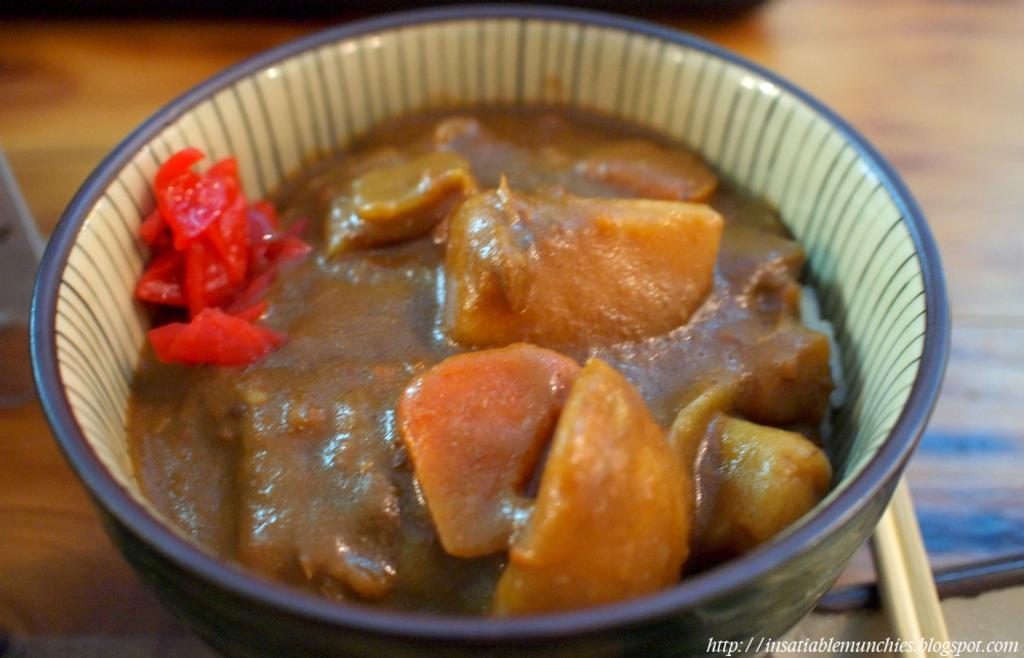What is in the bowl that is visible in the image? There is a bowl with food in the image. Can you describe the appearance of the food in the bowl? The food has brown and red colors. What colors are used for the bowl in the image? The bowl has blue and cream colors. On what surface is the bowl placed in the image? The bowl is on a brown surface. How many trees can be seen in the image? There are no trees visible in the image; it features a bowl with food on a brown surface. What type of coat is worn by the person in the image? There is no person or coat present in the image. 